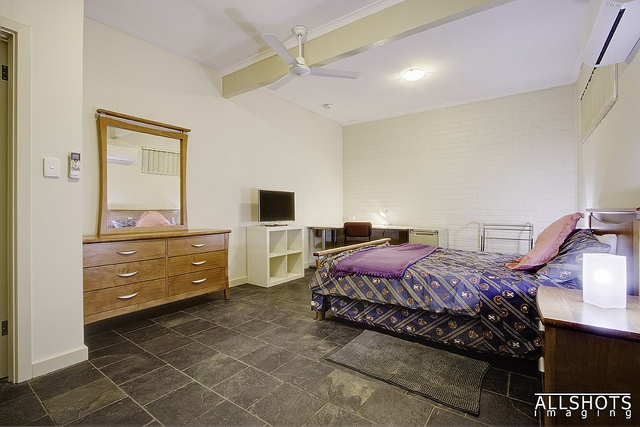Describe the objects in this image and their specific colors. I can see bed in darkgray, black, gray, and purple tones, tv in darkgray and black tones, and chair in darkgray, black, maroon, and beige tones in this image. 